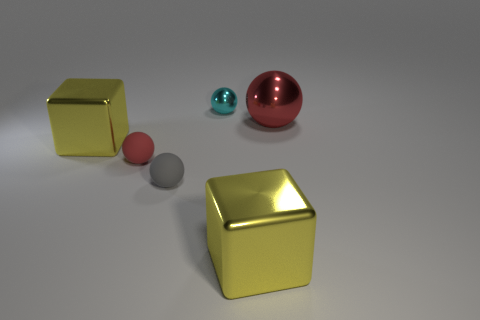How many red balls must be subtracted to get 1 red balls? 1 Subtract 1 balls. How many balls are left? 3 Subtract all blue spheres. Subtract all blue blocks. How many spheres are left? 4 Add 4 red metal spheres. How many objects exist? 10 Subtract all spheres. How many objects are left? 2 Subtract 0 purple balls. How many objects are left? 6 Subtract all shiny blocks. Subtract all gray rubber things. How many objects are left? 3 Add 6 red metallic things. How many red metallic things are left? 7 Add 2 large red metallic spheres. How many large red metallic spheres exist? 3 